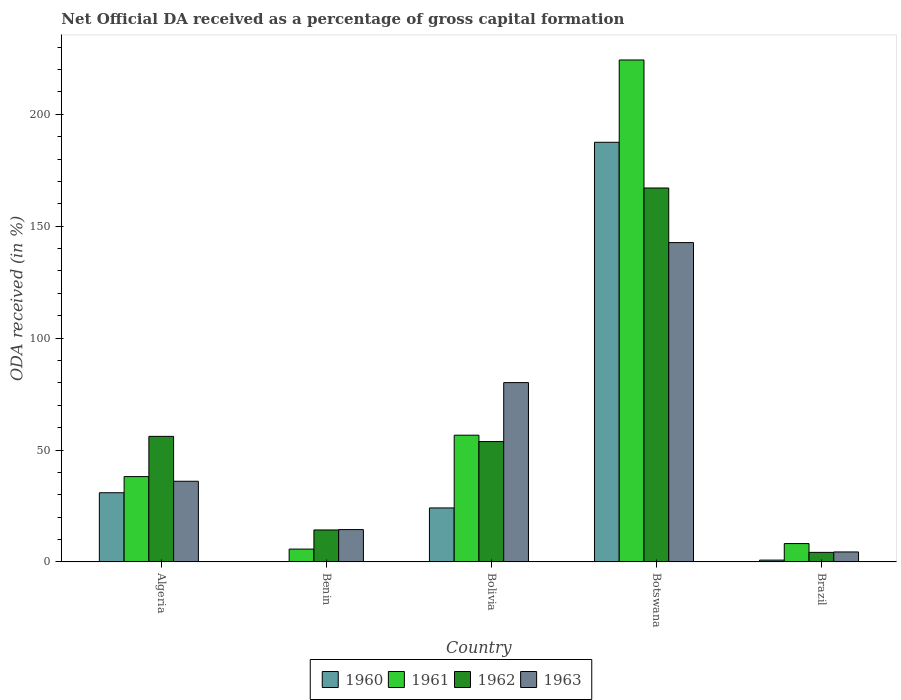Are the number of bars per tick equal to the number of legend labels?
Your answer should be very brief. Yes. Are the number of bars on each tick of the X-axis equal?
Make the answer very short. Yes. What is the label of the 4th group of bars from the left?
Provide a succinct answer. Botswana. In how many cases, is the number of bars for a given country not equal to the number of legend labels?
Provide a short and direct response. 0. What is the net ODA received in 1960 in Bolivia?
Your answer should be very brief. 24.12. Across all countries, what is the maximum net ODA received in 1963?
Give a very brief answer. 142.68. Across all countries, what is the minimum net ODA received in 1963?
Provide a short and direct response. 4.45. In which country was the net ODA received in 1962 maximum?
Your answer should be very brief. Botswana. What is the total net ODA received in 1960 in the graph?
Provide a short and direct response. 243.39. What is the difference between the net ODA received in 1960 in Algeria and that in Benin?
Your answer should be compact. 30.82. What is the difference between the net ODA received in 1961 in Brazil and the net ODA received in 1960 in Algeria?
Your answer should be compact. -22.71. What is the average net ODA received in 1962 per country?
Offer a very short reply. 59.09. What is the difference between the net ODA received of/in 1960 and net ODA received of/in 1961 in Benin?
Keep it short and to the point. -5.65. In how many countries, is the net ODA received in 1963 greater than 50 %?
Give a very brief answer. 2. What is the ratio of the net ODA received in 1960 in Benin to that in Bolivia?
Keep it short and to the point. 0. Is the net ODA received in 1963 in Benin less than that in Botswana?
Your answer should be compact. Yes. Is the difference between the net ODA received in 1960 in Bolivia and Botswana greater than the difference between the net ODA received in 1961 in Bolivia and Botswana?
Offer a very short reply. Yes. What is the difference between the highest and the second highest net ODA received in 1962?
Provide a succinct answer. 2.31. What is the difference between the highest and the lowest net ODA received in 1960?
Make the answer very short. 187.41. Is the sum of the net ODA received in 1963 in Algeria and Brazil greater than the maximum net ODA received in 1960 across all countries?
Offer a very short reply. No. What does the 2nd bar from the right in Benin represents?
Ensure brevity in your answer.  1962. How many bars are there?
Offer a terse response. 20. Are all the bars in the graph horizontal?
Make the answer very short. No. How many countries are there in the graph?
Offer a very short reply. 5. Are the values on the major ticks of Y-axis written in scientific E-notation?
Give a very brief answer. No. Where does the legend appear in the graph?
Your answer should be compact. Bottom center. What is the title of the graph?
Offer a very short reply. Net Official DA received as a percentage of gross capital formation. What is the label or title of the Y-axis?
Your response must be concise. ODA received (in %). What is the ODA received (in %) in 1960 in Algeria?
Your answer should be very brief. 30.9. What is the ODA received (in %) of 1961 in Algeria?
Ensure brevity in your answer.  38.11. What is the ODA received (in %) in 1962 in Algeria?
Offer a very short reply. 56.09. What is the ODA received (in %) in 1963 in Algeria?
Provide a succinct answer. 36.04. What is the ODA received (in %) of 1960 in Benin?
Give a very brief answer. 0.08. What is the ODA received (in %) of 1961 in Benin?
Your response must be concise. 5.73. What is the ODA received (in %) of 1962 in Benin?
Your answer should be compact. 14.28. What is the ODA received (in %) of 1963 in Benin?
Keep it short and to the point. 14.44. What is the ODA received (in %) in 1960 in Bolivia?
Provide a succinct answer. 24.12. What is the ODA received (in %) in 1961 in Bolivia?
Offer a very short reply. 56.62. What is the ODA received (in %) in 1962 in Bolivia?
Make the answer very short. 53.77. What is the ODA received (in %) in 1963 in Bolivia?
Your response must be concise. 80.11. What is the ODA received (in %) of 1960 in Botswana?
Make the answer very short. 187.49. What is the ODA received (in %) of 1961 in Botswana?
Provide a succinct answer. 224.27. What is the ODA received (in %) in 1962 in Botswana?
Your response must be concise. 167.07. What is the ODA received (in %) of 1963 in Botswana?
Offer a terse response. 142.68. What is the ODA received (in %) in 1960 in Brazil?
Provide a short and direct response. 0.81. What is the ODA received (in %) in 1961 in Brazil?
Your answer should be very brief. 8.19. What is the ODA received (in %) in 1962 in Brazil?
Ensure brevity in your answer.  4.26. What is the ODA received (in %) in 1963 in Brazil?
Keep it short and to the point. 4.45. Across all countries, what is the maximum ODA received (in %) of 1960?
Your answer should be very brief. 187.49. Across all countries, what is the maximum ODA received (in %) of 1961?
Provide a succinct answer. 224.27. Across all countries, what is the maximum ODA received (in %) in 1962?
Provide a short and direct response. 167.07. Across all countries, what is the maximum ODA received (in %) of 1963?
Offer a very short reply. 142.68. Across all countries, what is the minimum ODA received (in %) of 1960?
Give a very brief answer. 0.08. Across all countries, what is the minimum ODA received (in %) in 1961?
Your answer should be compact. 5.73. Across all countries, what is the minimum ODA received (in %) in 1962?
Your response must be concise. 4.26. Across all countries, what is the minimum ODA received (in %) of 1963?
Make the answer very short. 4.45. What is the total ODA received (in %) of 1960 in the graph?
Ensure brevity in your answer.  243.39. What is the total ODA received (in %) in 1961 in the graph?
Your response must be concise. 332.92. What is the total ODA received (in %) of 1962 in the graph?
Your response must be concise. 295.47. What is the total ODA received (in %) of 1963 in the graph?
Your response must be concise. 277.72. What is the difference between the ODA received (in %) of 1960 in Algeria and that in Benin?
Your response must be concise. 30.82. What is the difference between the ODA received (in %) of 1961 in Algeria and that in Benin?
Give a very brief answer. 32.39. What is the difference between the ODA received (in %) in 1962 in Algeria and that in Benin?
Make the answer very short. 41.81. What is the difference between the ODA received (in %) in 1963 in Algeria and that in Benin?
Ensure brevity in your answer.  21.6. What is the difference between the ODA received (in %) in 1960 in Algeria and that in Bolivia?
Your answer should be very brief. 6.78. What is the difference between the ODA received (in %) of 1961 in Algeria and that in Bolivia?
Your answer should be very brief. -18.5. What is the difference between the ODA received (in %) in 1962 in Algeria and that in Bolivia?
Offer a terse response. 2.31. What is the difference between the ODA received (in %) of 1963 in Algeria and that in Bolivia?
Give a very brief answer. -44.08. What is the difference between the ODA received (in %) in 1960 in Algeria and that in Botswana?
Your response must be concise. -156.58. What is the difference between the ODA received (in %) in 1961 in Algeria and that in Botswana?
Offer a terse response. -186.15. What is the difference between the ODA received (in %) of 1962 in Algeria and that in Botswana?
Make the answer very short. -110.98. What is the difference between the ODA received (in %) in 1963 in Algeria and that in Botswana?
Provide a short and direct response. -106.64. What is the difference between the ODA received (in %) of 1960 in Algeria and that in Brazil?
Your answer should be very brief. 30.09. What is the difference between the ODA received (in %) of 1961 in Algeria and that in Brazil?
Make the answer very short. 29.92. What is the difference between the ODA received (in %) in 1962 in Algeria and that in Brazil?
Your answer should be very brief. 51.83. What is the difference between the ODA received (in %) in 1963 in Algeria and that in Brazil?
Make the answer very short. 31.59. What is the difference between the ODA received (in %) of 1960 in Benin and that in Bolivia?
Give a very brief answer. -24.04. What is the difference between the ODA received (in %) of 1961 in Benin and that in Bolivia?
Your response must be concise. -50.89. What is the difference between the ODA received (in %) of 1962 in Benin and that in Bolivia?
Your answer should be compact. -39.5. What is the difference between the ODA received (in %) of 1963 in Benin and that in Bolivia?
Make the answer very short. -65.67. What is the difference between the ODA received (in %) of 1960 in Benin and that in Botswana?
Your answer should be very brief. -187.41. What is the difference between the ODA received (in %) of 1961 in Benin and that in Botswana?
Ensure brevity in your answer.  -218.54. What is the difference between the ODA received (in %) of 1962 in Benin and that in Botswana?
Make the answer very short. -152.79. What is the difference between the ODA received (in %) in 1963 in Benin and that in Botswana?
Offer a very short reply. -128.24. What is the difference between the ODA received (in %) in 1960 in Benin and that in Brazil?
Offer a terse response. -0.73. What is the difference between the ODA received (in %) of 1961 in Benin and that in Brazil?
Keep it short and to the point. -2.46. What is the difference between the ODA received (in %) of 1962 in Benin and that in Brazil?
Provide a succinct answer. 10.01. What is the difference between the ODA received (in %) in 1963 in Benin and that in Brazil?
Offer a very short reply. 9.99. What is the difference between the ODA received (in %) in 1960 in Bolivia and that in Botswana?
Ensure brevity in your answer.  -163.37. What is the difference between the ODA received (in %) of 1961 in Bolivia and that in Botswana?
Your response must be concise. -167.65. What is the difference between the ODA received (in %) of 1962 in Bolivia and that in Botswana?
Provide a succinct answer. -113.3. What is the difference between the ODA received (in %) of 1963 in Bolivia and that in Botswana?
Provide a succinct answer. -62.56. What is the difference between the ODA received (in %) of 1960 in Bolivia and that in Brazil?
Ensure brevity in your answer.  23.31. What is the difference between the ODA received (in %) in 1961 in Bolivia and that in Brazil?
Offer a very short reply. 48.42. What is the difference between the ODA received (in %) of 1962 in Bolivia and that in Brazil?
Give a very brief answer. 49.51. What is the difference between the ODA received (in %) in 1963 in Bolivia and that in Brazil?
Keep it short and to the point. 75.67. What is the difference between the ODA received (in %) in 1960 in Botswana and that in Brazil?
Your answer should be compact. 186.68. What is the difference between the ODA received (in %) in 1961 in Botswana and that in Brazil?
Make the answer very short. 216.07. What is the difference between the ODA received (in %) of 1962 in Botswana and that in Brazil?
Make the answer very short. 162.81. What is the difference between the ODA received (in %) in 1963 in Botswana and that in Brazil?
Your response must be concise. 138.23. What is the difference between the ODA received (in %) in 1960 in Algeria and the ODA received (in %) in 1961 in Benin?
Your response must be concise. 25.17. What is the difference between the ODA received (in %) in 1960 in Algeria and the ODA received (in %) in 1962 in Benin?
Offer a terse response. 16.62. What is the difference between the ODA received (in %) in 1960 in Algeria and the ODA received (in %) in 1963 in Benin?
Keep it short and to the point. 16.46. What is the difference between the ODA received (in %) in 1961 in Algeria and the ODA received (in %) in 1962 in Benin?
Ensure brevity in your answer.  23.84. What is the difference between the ODA received (in %) in 1961 in Algeria and the ODA received (in %) in 1963 in Benin?
Offer a very short reply. 23.67. What is the difference between the ODA received (in %) in 1962 in Algeria and the ODA received (in %) in 1963 in Benin?
Give a very brief answer. 41.65. What is the difference between the ODA received (in %) in 1960 in Algeria and the ODA received (in %) in 1961 in Bolivia?
Give a very brief answer. -25.71. What is the difference between the ODA received (in %) in 1960 in Algeria and the ODA received (in %) in 1962 in Bolivia?
Provide a short and direct response. -22.87. What is the difference between the ODA received (in %) in 1960 in Algeria and the ODA received (in %) in 1963 in Bolivia?
Your answer should be compact. -49.21. What is the difference between the ODA received (in %) in 1961 in Algeria and the ODA received (in %) in 1962 in Bolivia?
Your response must be concise. -15.66. What is the difference between the ODA received (in %) in 1961 in Algeria and the ODA received (in %) in 1963 in Bolivia?
Provide a short and direct response. -42. What is the difference between the ODA received (in %) of 1962 in Algeria and the ODA received (in %) of 1963 in Bolivia?
Ensure brevity in your answer.  -24.03. What is the difference between the ODA received (in %) of 1960 in Algeria and the ODA received (in %) of 1961 in Botswana?
Give a very brief answer. -193.36. What is the difference between the ODA received (in %) in 1960 in Algeria and the ODA received (in %) in 1962 in Botswana?
Offer a very short reply. -136.17. What is the difference between the ODA received (in %) in 1960 in Algeria and the ODA received (in %) in 1963 in Botswana?
Provide a succinct answer. -111.78. What is the difference between the ODA received (in %) of 1961 in Algeria and the ODA received (in %) of 1962 in Botswana?
Your answer should be compact. -128.96. What is the difference between the ODA received (in %) of 1961 in Algeria and the ODA received (in %) of 1963 in Botswana?
Offer a terse response. -104.56. What is the difference between the ODA received (in %) in 1962 in Algeria and the ODA received (in %) in 1963 in Botswana?
Provide a succinct answer. -86.59. What is the difference between the ODA received (in %) in 1960 in Algeria and the ODA received (in %) in 1961 in Brazil?
Provide a short and direct response. 22.71. What is the difference between the ODA received (in %) in 1960 in Algeria and the ODA received (in %) in 1962 in Brazil?
Your response must be concise. 26.64. What is the difference between the ODA received (in %) of 1960 in Algeria and the ODA received (in %) of 1963 in Brazil?
Ensure brevity in your answer.  26.45. What is the difference between the ODA received (in %) of 1961 in Algeria and the ODA received (in %) of 1962 in Brazil?
Make the answer very short. 33.85. What is the difference between the ODA received (in %) in 1961 in Algeria and the ODA received (in %) in 1963 in Brazil?
Offer a terse response. 33.67. What is the difference between the ODA received (in %) in 1962 in Algeria and the ODA received (in %) in 1963 in Brazil?
Offer a terse response. 51.64. What is the difference between the ODA received (in %) of 1960 in Benin and the ODA received (in %) of 1961 in Bolivia?
Your response must be concise. -56.54. What is the difference between the ODA received (in %) of 1960 in Benin and the ODA received (in %) of 1962 in Bolivia?
Your response must be concise. -53.7. What is the difference between the ODA received (in %) in 1960 in Benin and the ODA received (in %) in 1963 in Bolivia?
Make the answer very short. -80.04. What is the difference between the ODA received (in %) in 1961 in Benin and the ODA received (in %) in 1962 in Bolivia?
Provide a short and direct response. -48.05. What is the difference between the ODA received (in %) of 1961 in Benin and the ODA received (in %) of 1963 in Bolivia?
Provide a short and direct response. -74.39. What is the difference between the ODA received (in %) of 1962 in Benin and the ODA received (in %) of 1963 in Bolivia?
Offer a very short reply. -65.84. What is the difference between the ODA received (in %) in 1960 in Benin and the ODA received (in %) in 1961 in Botswana?
Make the answer very short. -224.19. What is the difference between the ODA received (in %) of 1960 in Benin and the ODA received (in %) of 1962 in Botswana?
Make the answer very short. -166.99. What is the difference between the ODA received (in %) in 1960 in Benin and the ODA received (in %) in 1963 in Botswana?
Your response must be concise. -142.6. What is the difference between the ODA received (in %) in 1961 in Benin and the ODA received (in %) in 1962 in Botswana?
Offer a terse response. -161.34. What is the difference between the ODA received (in %) in 1961 in Benin and the ODA received (in %) in 1963 in Botswana?
Offer a very short reply. -136.95. What is the difference between the ODA received (in %) in 1962 in Benin and the ODA received (in %) in 1963 in Botswana?
Keep it short and to the point. -128.4. What is the difference between the ODA received (in %) of 1960 in Benin and the ODA received (in %) of 1961 in Brazil?
Your response must be concise. -8.11. What is the difference between the ODA received (in %) in 1960 in Benin and the ODA received (in %) in 1962 in Brazil?
Give a very brief answer. -4.19. What is the difference between the ODA received (in %) in 1960 in Benin and the ODA received (in %) in 1963 in Brazil?
Keep it short and to the point. -4.37. What is the difference between the ODA received (in %) in 1961 in Benin and the ODA received (in %) in 1962 in Brazil?
Keep it short and to the point. 1.46. What is the difference between the ODA received (in %) in 1961 in Benin and the ODA received (in %) in 1963 in Brazil?
Offer a very short reply. 1.28. What is the difference between the ODA received (in %) of 1962 in Benin and the ODA received (in %) of 1963 in Brazil?
Provide a short and direct response. 9.83. What is the difference between the ODA received (in %) in 1960 in Bolivia and the ODA received (in %) in 1961 in Botswana?
Make the answer very short. -200.15. What is the difference between the ODA received (in %) in 1960 in Bolivia and the ODA received (in %) in 1962 in Botswana?
Provide a succinct answer. -142.95. What is the difference between the ODA received (in %) of 1960 in Bolivia and the ODA received (in %) of 1963 in Botswana?
Your answer should be very brief. -118.56. What is the difference between the ODA received (in %) in 1961 in Bolivia and the ODA received (in %) in 1962 in Botswana?
Your response must be concise. -110.45. What is the difference between the ODA received (in %) of 1961 in Bolivia and the ODA received (in %) of 1963 in Botswana?
Provide a short and direct response. -86.06. What is the difference between the ODA received (in %) of 1962 in Bolivia and the ODA received (in %) of 1963 in Botswana?
Provide a succinct answer. -88.9. What is the difference between the ODA received (in %) of 1960 in Bolivia and the ODA received (in %) of 1961 in Brazil?
Keep it short and to the point. 15.93. What is the difference between the ODA received (in %) of 1960 in Bolivia and the ODA received (in %) of 1962 in Brazil?
Offer a very short reply. 19.86. What is the difference between the ODA received (in %) in 1960 in Bolivia and the ODA received (in %) in 1963 in Brazil?
Provide a short and direct response. 19.67. What is the difference between the ODA received (in %) of 1961 in Bolivia and the ODA received (in %) of 1962 in Brazil?
Your response must be concise. 52.35. What is the difference between the ODA received (in %) in 1961 in Bolivia and the ODA received (in %) in 1963 in Brazil?
Offer a terse response. 52.17. What is the difference between the ODA received (in %) of 1962 in Bolivia and the ODA received (in %) of 1963 in Brazil?
Offer a very short reply. 49.33. What is the difference between the ODA received (in %) in 1960 in Botswana and the ODA received (in %) in 1961 in Brazil?
Make the answer very short. 179.29. What is the difference between the ODA received (in %) of 1960 in Botswana and the ODA received (in %) of 1962 in Brazil?
Offer a terse response. 183.22. What is the difference between the ODA received (in %) of 1960 in Botswana and the ODA received (in %) of 1963 in Brazil?
Make the answer very short. 183.04. What is the difference between the ODA received (in %) in 1961 in Botswana and the ODA received (in %) in 1962 in Brazil?
Provide a short and direct response. 220. What is the difference between the ODA received (in %) in 1961 in Botswana and the ODA received (in %) in 1963 in Brazil?
Make the answer very short. 219.82. What is the difference between the ODA received (in %) in 1962 in Botswana and the ODA received (in %) in 1963 in Brazil?
Keep it short and to the point. 162.62. What is the average ODA received (in %) in 1960 per country?
Offer a very short reply. 48.68. What is the average ODA received (in %) of 1961 per country?
Your answer should be very brief. 66.58. What is the average ODA received (in %) of 1962 per country?
Offer a very short reply. 59.09. What is the average ODA received (in %) in 1963 per country?
Offer a very short reply. 55.54. What is the difference between the ODA received (in %) of 1960 and ODA received (in %) of 1961 in Algeria?
Ensure brevity in your answer.  -7.21. What is the difference between the ODA received (in %) of 1960 and ODA received (in %) of 1962 in Algeria?
Keep it short and to the point. -25.19. What is the difference between the ODA received (in %) of 1960 and ODA received (in %) of 1963 in Algeria?
Make the answer very short. -5.14. What is the difference between the ODA received (in %) in 1961 and ODA received (in %) in 1962 in Algeria?
Give a very brief answer. -17.98. What is the difference between the ODA received (in %) in 1961 and ODA received (in %) in 1963 in Algeria?
Your response must be concise. 2.08. What is the difference between the ODA received (in %) of 1962 and ODA received (in %) of 1963 in Algeria?
Offer a very short reply. 20.05. What is the difference between the ODA received (in %) of 1960 and ODA received (in %) of 1961 in Benin?
Give a very brief answer. -5.65. What is the difference between the ODA received (in %) in 1960 and ODA received (in %) in 1962 in Benin?
Ensure brevity in your answer.  -14.2. What is the difference between the ODA received (in %) in 1960 and ODA received (in %) in 1963 in Benin?
Your answer should be compact. -14.36. What is the difference between the ODA received (in %) of 1961 and ODA received (in %) of 1962 in Benin?
Make the answer very short. -8.55. What is the difference between the ODA received (in %) of 1961 and ODA received (in %) of 1963 in Benin?
Your answer should be compact. -8.71. What is the difference between the ODA received (in %) in 1962 and ODA received (in %) in 1963 in Benin?
Your answer should be very brief. -0.16. What is the difference between the ODA received (in %) in 1960 and ODA received (in %) in 1961 in Bolivia?
Your answer should be compact. -32.5. What is the difference between the ODA received (in %) of 1960 and ODA received (in %) of 1962 in Bolivia?
Ensure brevity in your answer.  -29.66. What is the difference between the ODA received (in %) of 1960 and ODA received (in %) of 1963 in Bolivia?
Your answer should be compact. -56. What is the difference between the ODA received (in %) in 1961 and ODA received (in %) in 1962 in Bolivia?
Give a very brief answer. 2.84. What is the difference between the ODA received (in %) in 1961 and ODA received (in %) in 1963 in Bolivia?
Make the answer very short. -23.5. What is the difference between the ODA received (in %) in 1962 and ODA received (in %) in 1963 in Bolivia?
Ensure brevity in your answer.  -26.34. What is the difference between the ODA received (in %) in 1960 and ODA received (in %) in 1961 in Botswana?
Your response must be concise. -36.78. What is the difference between the ODA received (in %) in 1960 and ODA received (in %) in 1962 in Botswana?
Keep it short and to the point. 20.42. What is the difference between the ODA received (in %) of 1960 and ODA received (in %) of 1963 in Botswana?
Make the answer very short. 44.81. What is the difference between the ODA received (in %) of 1961 and ODA received (in %) of 1962 in Botswana?
Your response must be concise. 57.2. What is the difference between the ODA received (in %) in 1961 and ODA received (in %) in 1963 in Botswana?
Your response must be concise. 81.59. What is the difference between the ODA received (in %) in 1962 and ODA received (in %) in 1963 in Botswana?
Offer a very short reply. 24.39. What is the difference between the ODA received (in %) of 1960 and ODA received (in %) of 1961 in Brazil?
Your response must be concise. -7.38. What is the difference between the ODA received (in %) of 1960 and ODA received (in %) of 1962 in Brazil?
Offer a terse response. -3.46. What is the difference between the ODA received (in %) of 1960 and ODA received (in %) of 1963 in Brazil?
Your answer should be very brief. -3.64. What is the difference between the ODA received (in %) in 1961 and ODA received (in %) in 1962 in Brazil?
Make the answer very short. 3.93. What is the difference between the ODA received (in %) of 1961 and ODA received (in %) of 1963 in Brazil?
Ensure brevity in your answer.  3.74. What is the difference between the ODA received (in %) of 1962 and ODA received (in %) of 1963 in Brazil?
Keep it short and to the point. -0.18. What is the ratio of the ODA received (in %) in 1960 in Algeria to that in Benin?
Your response must be concise. 399.3. What is the ratio of the ODA received (in %) in 1961 in Algeria to that in Benin?
Offer a terse response. 6.65. What is the ratio of the ODA received (in %) in 1962 in Algeria to that in Benin?
Your answer should be very brief. 3.93. What is the ratio of the ODA received (in %) in 1963 in Algeria to that in Benin?
Your answer should be very brief. 2.5. What is the ratio of the ODA received (in %) in 1960 in Algeria to that in Bolivia?
Your response must be concise. 1.28. What is the ratio of the ODA received (in %) in 1961 in Algeria to that in Bolivia?
Offer a very short reply. 0.67. What is the ratio of the ODA received (in %) in 1962 in Algeria to that in Bolivia?
Provide a succinct answer. 1.04. What is the ratio of the ODA received (in %) in 1963 in Algeria to that in Bolivia?
Keep it short and to the point. 0.45. What is the ratio of the ODA received (in %) of 1960 in Algeria to that in Botswana?
Offer a terse response. 0.16. What is the ratio of the ODA received (in %) in 1961 in Algeria to that in Botswana?
Provide a short and direct response. 0.17. What is the ratio of the ODA received (in %) in 1962 in Algeria to that in Botswana?
Your response must be concise. 0.34. What is the ratio of the ODA received (in %) in 1963 in Algeria to that in Botswana?
Make the answer very short. 0.25. What is the ratio of the ODA received (in %) of 1960 in Algeria to that in Brazil?
Keep it short and to the point. 38.25. What is the ratio of the ODA received (in %) of 1961 in Algeria to that in Brazil?
Ensure brevity in your answer.  4.65. What is the ratio of the ODA received (in %) of 1962 in Algeria to that in Brazil?
Ensure brevity in your answer.  13.15. What is the ratio of the ODA received (in %) in 1963 in Algeria to that in Brazil?
Provide a succinct answer. 8.1. What is the ratio of the ODA received (in %) of 1960 in Benin to that in Bolivia?
Offer a very short reply. 0. What is the ratio of the ODA received (in %) in 1961 in Benin to that in Bolivia?
Provide a short and direct response. 0.1. What is the ratio of the ODA received (in %) in 1962 in Benin to that in Bolivia?
Your answer should be compact. 0.27. What is the ratio of the ODA received (in %) of 1963 in Benin to that in Bolivia?
Provide a short and direct response. 0.18. What is the ratio of the ODA received (in %) of 1960 in Benin to that in Botswana?
Provide a short and direct response. 0. What is the ratio of the ODA received (in %) of 1961 in Benin to that in Botswana?
Keep it short and to the point. 0.03. What is the ratio of the ODA received (in %) in 1962 in Benin to that in Botswana?
Offer a terse response. 0.09. What is the ratio of the ODA received (in %) of 1963 in Benin to that in Botswana?
Provide a short and direct response. 0.1. What is the ratio of the ODA received (in %) in 1960 in Benin to that in Brazil?
Make the answer very short. 0.1. What is the ratio of the ODA received (in %) of 1961 in Benin to that in Brazil?
Provide a succinct answer. 0.7. What is the ratio of the ODA received (in %) in 1962 in Benin to that in Brazil?
Offer a very short reply. 3.35. What is the ratio of the ODA received (in %) of 1963 in Benin to that in Brazil?
Your answer should be very brief. 3.25. What is the ratio of the ODA received (in %) in 1960 in Bolivia to that in Botswana?
Ensure brevity in your answer.  0.13. What is the ratio of the ODA received (in %) in 1961 in Bolivia to that in Botswana?
Make the answer very short. 0.25. What is the ratio of the ODA received (in %) in 1962 in Bolivia to that in Botswana?
Keep it short and to the point. 0.32. What is the ratio of the ODA received (in %) of 1963 in Bolivia to that in Botswana?
Make the answer very short. 0.56. What is the ratio of the ODA received (in %) of 1960 in Bolivia to that in Brazil?
Keep it short and to the point. 29.85. What is the ratio of the ODA received (in %) in 1961 in Bolivia to that in Brazil?
Give a very brief answer. 6.91. What is the ratio of the ODA received (in %) in 1962 in Bolivia to that in Brazil?
Your answer should be compact. 12.61. What is the ratio of the ODA received (in %) in 1963 in Bolivia to that in Brazil?
Provide a short and direct response. 18.01. What is the ratio of the ODA received (in %) of 1960 in Botswana to that in Brazil?
Your response must be concise. 232.07. What is the ratio of the ODA received (in %) in 1961 in Botswana to that in Brazil?
Provide a short and direct response. 27.38. What is the ratio of the ODA received (in %) of 1962 in Botswana to that in Brazil?
Your answer should be very brief. 39.18. What is the ratio of the ODA received (in %) of 1963 in Botswana to that in Brazil?
Your response must be concise. 32.07. What is the difference between the highest and the second highest ODA received (in %) of 1960?
Give a very brief answer. 156.58. What is the difference between the highest and the second highest ODA received (in %) of 1961?
Your answer should be very brief. 167.65. What is the difference between the highest and the second highest ODA received (in %) in 1962?
Make the answer very short. 110.98. What is the difference between the highest and the second highest ODA received (in %) in 1963?
Provide a short and direct response. 62.56. What is the difference between the highest and the lowest ODA received (in %) in 1960?
Ensure brevity in your answer.  187.41. What is the difference between the highest and the lowest ODA received (in %) of 1961?
Provide a short and direct response. 218.54. What is the difference between the highest and the lowest ODA received (in %) of 1962?
Offer a terse response. 162.81. What is the difference between the highest and the lowest ODA received (in %) of 1963?
Offer a very short reply. 138.23. 